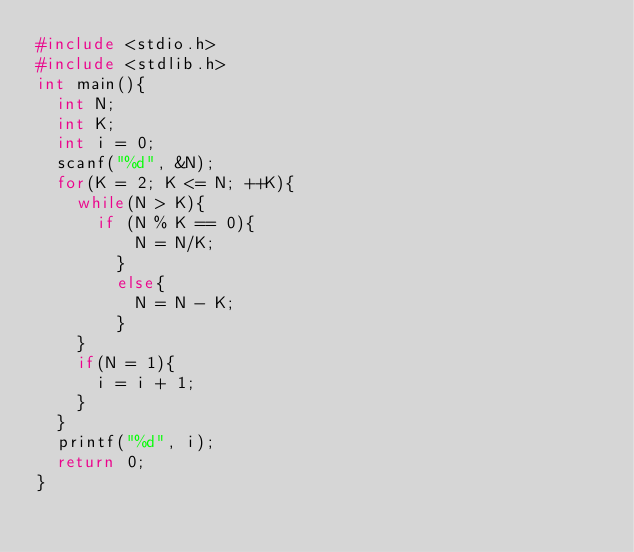Convert code to text. <code><loc_0><loc_0><loc_500><loc_500><_C_>#include <stdio.h>
#include <stdlib.h>
int main(){
  int N;
  int K;
  int i = 0;
  scanf("%d", &N);
  for(K = 2; K <= N; ++K){
  	while(N > K){
    	if (N % K == 0){
          N = N/K;
        }
      	else{
          N = N - K;
        }
    }
    if(N = 1){
      i = i + 1;
    }
  }
  printf("%d", i);
  return 0;
}</code> 